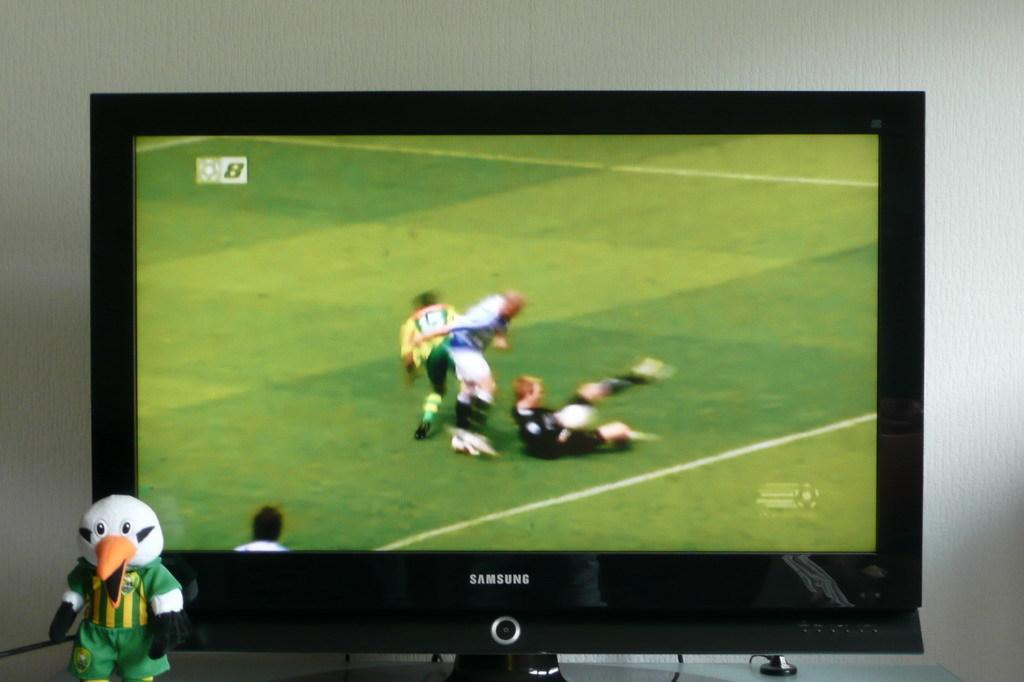<image>
Relay a brief, clear account of the picture shown. A football game being played on a Samsung black tv. 